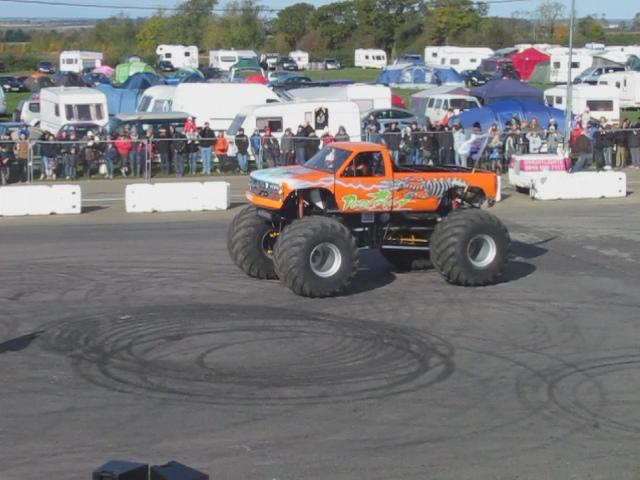What are the circular patterns on the ground?

Choices:
A) abstract drawing
B) paint
C) tire tracks
D) cracks tire tracks 